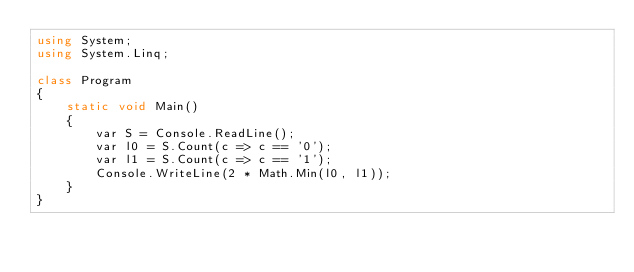<code> <loc_0><loc_0><loc_500><loc_500><_C#_>using System;
using System.Linq;

class Program
{
    static void Main()
    {
        var S = Console.ReadLine();
        var l0 = S.Count(c => c == '0');
        var l1 = S.Count(c => c == '1');
        Console.WriteLine(2 * Math.Min(l0, l1));
    }
}
</code> 